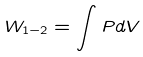<formula> <loc_0><loc_0><loc_500><loc_500>W _ { 1 - 2 } = \int P d V</formula> 